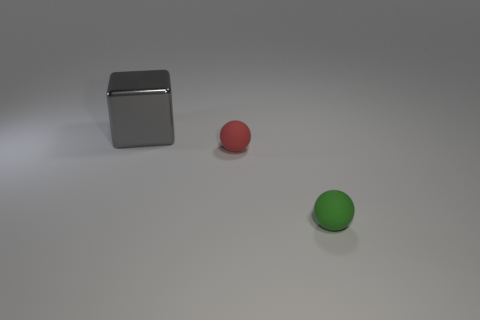There is a gray metallic thing behind the tiny red object; is its size the same as the rubber ball that is on the right side of the small red matte sphere?
Your answer should be compact. No. Are there any other blocks made of the same material as the big cube?
Provide a short and direct response. No. What number of things are either objects that are in front of the large cube or gray things?
Ensure brevity in your answer.  3. Is the small sphere that is to the left of the small green ball made of the same material as the small green ball?
Your answer should be very brief. Yes. Do the metallic object and the small red matte object have the same shape?
Provide a succinct answer. No. There is a small thing behind the green thing; what number of small rubber balls are to the right of it?
Ensure brevity in your answer.  1. There is a tiny red object that is the same shape as the tiny green matte thing; what material is it?
Provide a succinct answer. Rubber. Do the tiny red ball and the ball that is in front of the red thing have the same material?
Provide a short and direct response. Yes. What shape is the thing right of the red sphere?
Give a very brief answer. Sphere. How many other objects are there of the same material as the large cube?
Your answer should be compact. 0. 